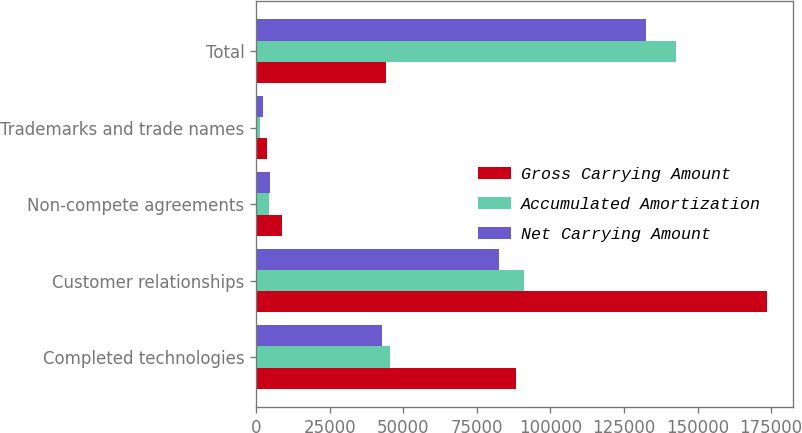Convert chart. <chart><loc_0><loc_0><loc_500><loc_500><stacked_bar_chart><ecel><fcel>Completed technologies<fcel>Customer relationships<fcel>Non-compete agreements<fcel>Trademarks and trade names<fcel>Total<nl><fcel>Gross Carrying Amount<fcel>88331<fcel>173600<fcel>8890<fcel>3700<fcel>44165.5<nl><fcel>Accumulated Amortization<fcel>45537<fcel>91160<fcel>4224<fcel>1188<fcel>142599<nl><fcel>Net Carrying Amount<fcel>42794<fcel>82440<fcel>4666<fcel>2512<fcel>132412<nl></chart> 